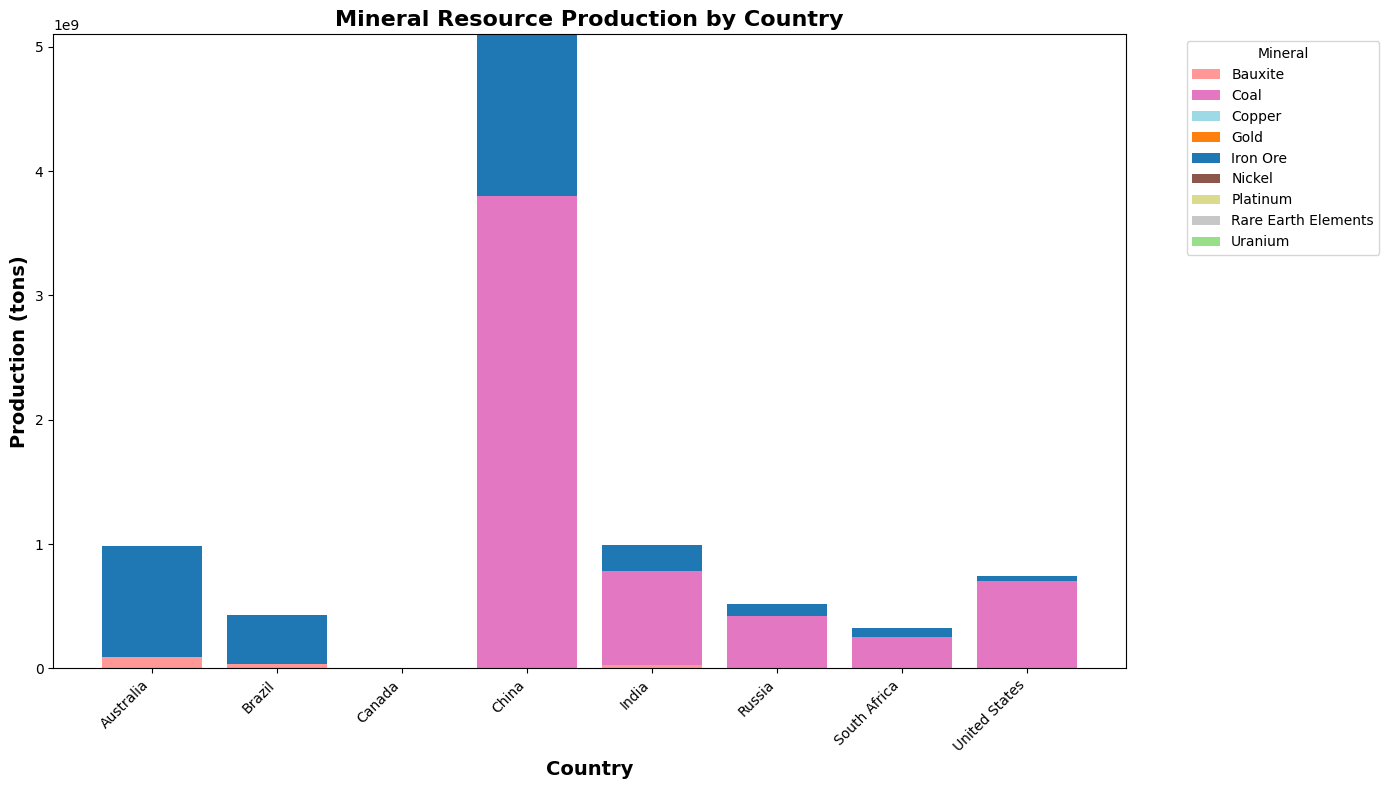Which country has the highest production of Iron Ore? To find the country with the highest Iron Ore production, look for the tallest bar segment corresponding to Iron Ore. China’s Iron Ore production segment is the tallest.
Answer: China How does Australia's Uranium production compare to Canada's? Compare the height of the Uranium bar segment for Australia and Canada. Australia's Uranium production bar segment is shorter than Canada’s.
Answer: Canada's is higher What are the combined Coal production volumes for India and the United States? Add the height of the Coal bar segments for India and the United States. India's Coal production is 760 million tons and the US's is 700 million tons. The combined total is 1460 million tons.
Answer: 1460 million tons Compare the overall production volumes of minerals in Australia and Russia. Sum the heights of all bar segments for Australia and Russia. Australia's total includes significant amounts of Iron Ore, Gold, Uranium, and Bauxite. Russia's includes Coal, Iron Ore, Gold, and Nickel but overall has smaller bars, indicating lower total production.
Answer: Australia produces more Among South Africa and Brazil, which country produces more Gold? Compare the heights of the Gold bar segments for South Africa and Brazil. South Africa’s Gold bar is taller than Brazil’s.
Answer: South Africa What is the total production of Gold by all countries? Sum the heights of all Gold bar segments. Gold production by country: Australia (330,000), Brazil (85,000), Canada (175,000), China (450,000), India (15,000), Russia (300,000), South Africa (90,000), United States (200,000). Total = 1,645,000 tons.
Answer: 1,645,000 tons How many countries produce Bauxite, and which country has the highest production? Count the bar segments corresponding to Bauxite and identify the tallest one. Bauxite is produced by Australia, Brazil, and India. Australia has the highest production.
Answer: 3 countries, Australia Which country produces Rare Earth Elements, and what is its production volume? Look for the bar segment labeled Rare Earth Elements and identify its country and height. Only China produces Rare Earth Elements, with a production volume of 120,000 tons.
Answer: China, 120,000 tons Differentiate the production volumes of Nickel in Canada and Russia. Compare the heights of the Nickel bar segments for Canada and Russia. Russia's Nickel bar is taller than Canada’s.
Answer: Russia produces more 